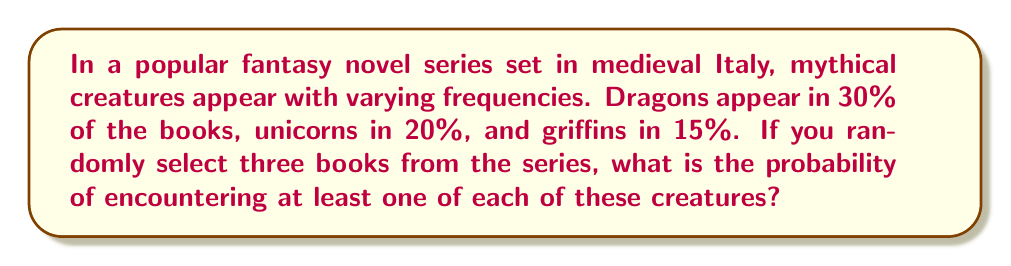Help me with this question. Let's approach this step-by-step:

1) First, we need to calculate the probability of encountering each creature in a single book:
   $P(\text{Dragon}) = 0.30$
   $P(\text{Unicorn}) = 0.20$
   $P(\text{Griffin}) = 0.15$

2) The probability of not encountering each creature in a single book is:
   $P(\text{No Dragon}) = 1 - 0.30 = 0.70$
   $P(\text{No Unicorn}) = 1 - 0.20 = 0.80$
   $P(\text{No Griffin}) = 1 - 0.15 = 0.85$

3) For three books, the probability of not encountering each creature at all is:
   $P(\text{No Dragons in 3 books}) = 0.70^3 = 0.343$
   $P(\text{No Unicorns in 3 books}) = 0.80^3 = 0.512$
   $P(\text{No Griffins in 3 books}) = 0.85^3 = 0.614$

4) The probability of encountering at least one of each creature is the opposite of not encountering at least one of them. This can be calculated using the inclusion-exclusion principle:

   $$P(\text{at least one of each}) = 1 - P(\text{missing at least one type})$$
   $$= 1 - [P(\text{No D}) + P(\text{No U}) + P(\text{No G}) - P(\text{No D and No U}) - P(\text{No D and No G}) - P(\text{No U and No G}) + P(\text{No D and No U and No G})]$$
   $$= 1 - [0.343 + 0.512 + 0.614 - (0.343 \times 0.512) - (0.343 \times 0.614) - (0.512 \times 0.614) + (0.343 \times 0.512 \times 0.614)]$$

5) Calculating this:
   $$= 1 - [1.469 - 0.176 - 0.211 - 0.314 + 0.108]$$
   $$= 1 - 0.876 = 0.124$$

Therefore, the probability of encountering at least one of each creature in three randomly selected books is approximately 0.124 or 12.4%.
Answer: $0.124$ or $12.4\%$ 